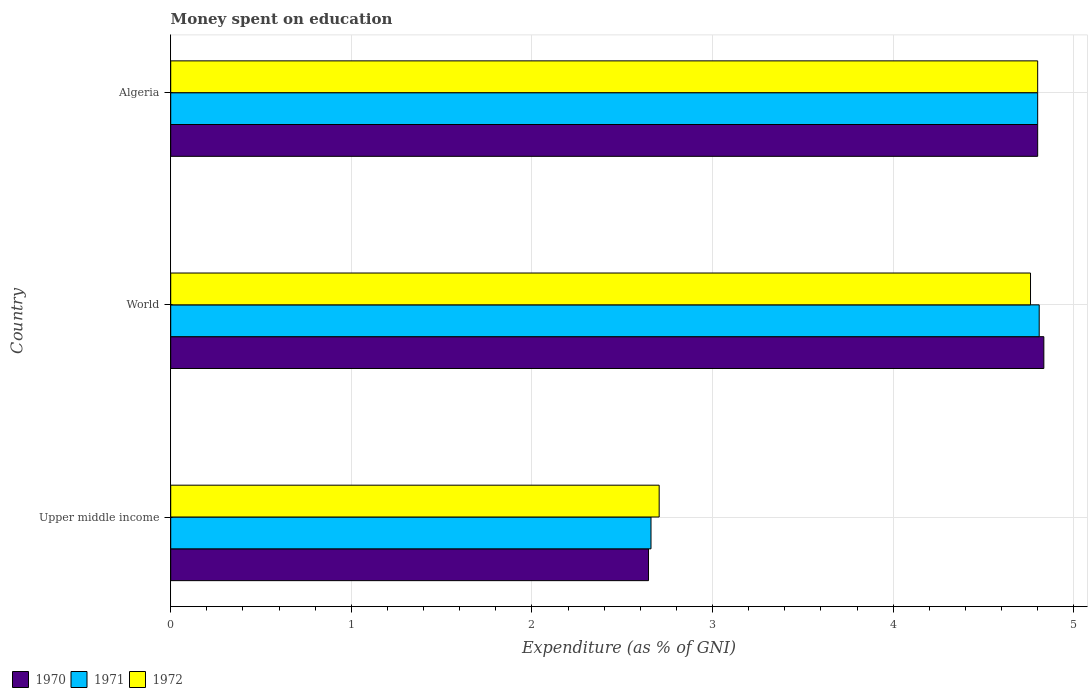How many groups of bars are there?
Provide a short and direct response. 3. How many bars are there on the 3rd tick from the top?
Offer a very short reply. 3. How many bars are there on the 3rd tick from the bottom?
Your answer should be very brief. 3. What is the label of the 1st group of bars from the top?
Your answer should be very brief. Algeria. What is the amount of money spent on education in 1970 in Upper middle income?
Make the answer very short. 2.65. Across all countries, what is the maximum amount of money spent on education in 1970?
Provide a short and direct response. 4.83. Across all countries, what is the minimum amount of money spent on education in 1971?
Ensure brevity in your answer.  2.66. In which country was the amount of money spent on education in 1970 maximum?
Ensure brevity in your answer.  World. In which country was the amount of money spent on education in 1972 minimum?
Your answer should be very brief. Upper middle income. What is the total amount of money spent on education in 1970 in the graph?
Provide a short and direct response. 12.28. What is the difference between the amount of money spent on education in 1970 in Algeria and that in World?
Ensure brevity in your answer.  -0.03. What is the difference between the amount of money spent on education in 1970 in Upper middle income and the amount of money spent on education in 1971 in World?
Ensure brevity in your answer.  -2.16. What is the average amount of money spent on education in 1970 per country?
Provide a succinct answer. 4.09. What is the difference between the amount of money spent on education in 1971 and amount of money spent on education in 1970 in Upper middle income?
Provide a short and direct response. 0.01. What is the ratio of the amount of money spent on education in 1970 in Algeria to that in World?
Offer a terse response. 0.99. Is the amount of money spent on education in 1971 in Upper middle income less than that in World?
Your answer should be very brief. Yes. What is the difference between the highest and the second highest amount of money spent on education in 1972?
Provide a short and direct response. 0.04. What is the difference between the highest and the lowest amount of money spent on education in 1971?
Give a very brief answer. 2.15. In how many countries, is the amount of money spent on education in 1971 greater than the average amount of money spent on education in 1971 taken over all countries?
Ensure brevity in your answer.  2. What does the 3rd bar from the bottom in Algeria represents?
Provide a short and direct response. 1972. What is the difference between two consecutive major ticks on the X-axis?
Provide a succinct answer. 1. Are the values on the major ticks of X-axis written in scientific E-notation?
Ensure brevity in your answer.  No. Does the graph contain any zero values?
Keep it short and to the point. No. What is the title of the graph?
Provide a succinct answer. Money spent on education. What is the label or title of the X-axis?
Ensure brevity in your answer.  Expenditure (as % of GNI). What is the label or title of the Y-axis?
Give a very brief answer. Country. What is the Expenditure (as % of GNI) in 1970 in Upper middle income?
Make the answer very short. 2.65. What is the Expenditure (as % of GNI) in 1971 in Upper middle income?
Offer a very short reply. 2.66. What is the Expenditure (as % of GNI) in 1972 in Upper middle income?
Your answer should be very brief. 2.7. What is the Expenditure (as % of GNI) of 1970 in World?
Ensure brevity in your answer.  4.83. What is the Expenditure (as % of GNI) in 1971 in World?
Your answer should be compact. 4.81. What is the Expenditure (as % of GNI) in 1972 in World?
Provide a succinct answer. 4.76. Across all countries, what is the maximum Expenditure (as % of GNI) of 1970?
Keep it short and to the point. 4.83. Across all countries, what is the maximum Expenditure (as % of GNI) in 1971?
Your response must be concise. 4.81. Across all countries, what is the maximum Expenditure (as % of GNI) in 1972?
Keep it short and to the point. 4.8. Across all countries, what is the minimum Expenditure (as % of GNI) in 1970?
Ensure brevity in your answer.  2.65. Across all countries, what is the minimum Expenditure (as % of GNI) in 1971?
Your answer should be very brief. 2.66. Across all countries, what is the minimum Expenditure (as % of GNI) in 1972?
Keep it short and to the point. 2.7. What is the total Expenditure (as % of GNI) of 1970 in the graph?
Your answer should be very brief. 12.28. What is the total Expenditure (as % of GNI) in 1971 in the graph?
Offer a terse response. 12.27. What is the total Expenditure (as % of GNI) in 1972 in the graph?
Offer a terse response. 12.26. What is the difference between the Expenditure (as % of GNI) of 1970 in Upper middle income and that in World?
Make the answer very short. -2.19. What is the difference between the Expenditure (as % of GNI) of 1971 in Upper middle income and that in World?
Offer a very short reply. -2.15. What is the difference between the Expenditure (as % of GNI) in 1972 in Upper middle income and that in World?
Make the answer very short. -2.06. What is the difference between the Expenditure (as % of GNI) of 1970 in Upper middle income and that in Algeria?
Offer a very short reply. -2.15. What is the difference between the Expenditure (as % of GNI) of 1971 in Upper middle income and that in Algeria?
Your response must be concise. -2.14. What is the difference between the Expenditure (as % of GNI) in 1972 in Upper middle income and that in Algeria?
Offer a very short reply. -2.1. What is the difference between the Expenditure (as % of GNI) in 1970 in World and that in Algeria?
Offer a terse response. 0.03. What is the difference between the Expenditure (as % of GNI) of 1971 in World and that in Algeria?
Provide a succinct answer. 0.01. What is the difference between the Expenditure (as % of GNI) in 1972 in World and that in Algeria?
Make the answer very short. -0.04. What is the difference between the Expenditure (as % of GNI) of 1970 in Upper middle income and the Expenditure (as % of GNI) of 1971 in World?
Offer a very short reply. -2.16. What is the difference between the Expenditure (as % of GNI) of 1970 in Upper middle income and the Expenditure (as % of GNI) of 1972 in World?
Offer a terse response. -2.12. What is the difference between the Expenditure (as % of GNI) in 1971 in Upper middle income and the Expenditure (as % of GNI) in 1972 in World?
Ensure brevity in your answer.  -2.1. What is the difference between the Expenditure (as % of GNI) in 1970 in Upper middle income and the Expenditure (as % of GNI) in 1971 in Algeria?
Provide a short and direct response. -2.15. What is the difference between the Expenditure (as % of GNI) of 1970 in Upper middle income and the Expenditure (as % of GNI) of 1972 in Algeria?
Your answer should be very brief. -2.15. What is the difference between the Expenditure (as % of GNI) in 1971 in Upper middle income and the Expenditure (as % of GNI) in 1972 in Algeria?
Ensure brevity in your answer.  -2.14. What is the difference between the Expenditure (as % of GNI) of 1970 in World and the Expenditure (as % of GNI) of 1971 in Algeria?
Provide a succinct answer. 0.03. What is the difference between the Expenditure (as % of GNI) of 1970 in World and the Expenditure (as % of GNI) of 1972 in Algeria?
Your answer should be compact. 0.03. What is the difference between the Expenditure (as % of GNI) in 1971 in World and the Expenditure (as % of GNI) in 1972 in Algeria?
Ensure brevity in your answer.  0.01. What is the average Expenditure (as % of GNI) in 1970 per country?
Your answer should be very brief. 4.09. What is the average Expenditure (as % of GNI) of 1971 per country?
Your response must be concise. 4.09. What is the average Expenditure (as % of GNI) of 1972 per country?
Your answer should be very brief. 4.09. What is the difference between the Expenditure (as % of GNI) of 1970 and Expenditure (as % of GNI) of 1971 in Upper middle income?
Ensure brevity in your answer.  -0.01. What is the difference between the Expenditure (as % of GNI) in 1970 and Expenditure (as % of GNI) in 1972 in Upper middle income?
Keep it short and to the point. -0.06. What is the difference between the Expenditure (as % of GNI) in 1971 and Expenditure (as % of GNI) in 1972 in Upper middle income?
Provide a succinct answer. -0.05. What is the difference between the Expenditure (as % of GNI) of 1970 and Expenditure (as % of GNI) of 1971 in World?
Your response must be concise. 0.03. What is the difference between the Expenditure (as % of GNI) in 1970 and Expenditure (as % of GNI) in 1972 in World?
Your answer should be compact. 0.07. What is the difference between the Expenditure (as % of GNI) in 1971 and Expenditure (as % of GNI) in 1972 in World?
Your answer should be compact. 0.05. What is the difference between the Expenditure (as % of GNI) in 1970 and Expenditure (as % of GNI) in 1971 in Algeria?
Your answer should be compact. 0. What is the difference between the Expenditure (as % of GNI) in 1971 and Expenditure (as % of GNI) in 1972 in Algeria?
Offer a very short reply. 0. What is the ratio of the Expenditure (as % of GNI) in 1970 in Upper middle income to that in World?
Your response must be concise. 0.55. What is the ratio of the Expenditure (as % of GNI) of 1971 in Upper middle income to that in World?
Your answer should be compact. 0.55. What is the ratio of the Expenditure (as % of GNI) of 1972 in Upper middle income to that in World?
Your answer should be compact. 0.57. What is the ratio of the Expenditure (as % of GNI) in 1970 in Upper middle income to that in Algeria?
Your response must be concise. 0.55. What is the ratio of the Expenditure (as % of GNI) in 1971 in Upper middle income to that in Algeria?
Give a very brief answer. 0.55. What is the ratio of the Expenditure (as % of GNI) in 1972 in Upper middle income to that in Algeria?
Offer a very short reply. 0.56. What is the ratio of the Expenditure (as % of GNI) in 1970 in World to that in Algeria?
Your answer should be compact. 1.01. What is the ratio of the Expenditure (as % of GNI) in 1971 in World to that in Algeria?
Your answer should be compact. 1. What is the ratio of the Expenditure (as % of GNI) in 1972 in World to that in Algeria?
Provide a succinct answer. 0.99. What is the difference between the highest and the second highest Expenditure (as % of GNI) of 1970?
Give a very brief answer. 0.03. What is the difference between the highest and the second highest Expenditure (as % of GNI) in 1971?
Offer a very short reply. 0.01. What is the difference between the highest and the second highest Expenditure (as % of GNI) in 1972?
Provide a short and direct response. 0.04. What is the difference between the highest and the lowest Expenditure (as % of GNI) in 1970?
Provide a short and direct response. 2.19. What is the difference between the highest and the lowest Expenditure (as % of GNI) in 1971?
Ensure brevity in your answer.  2.15. What is the difference between the highest and the lowest Expenditure (as % of GNI) in 1972?
Your answer should be very brief. 2.1. 